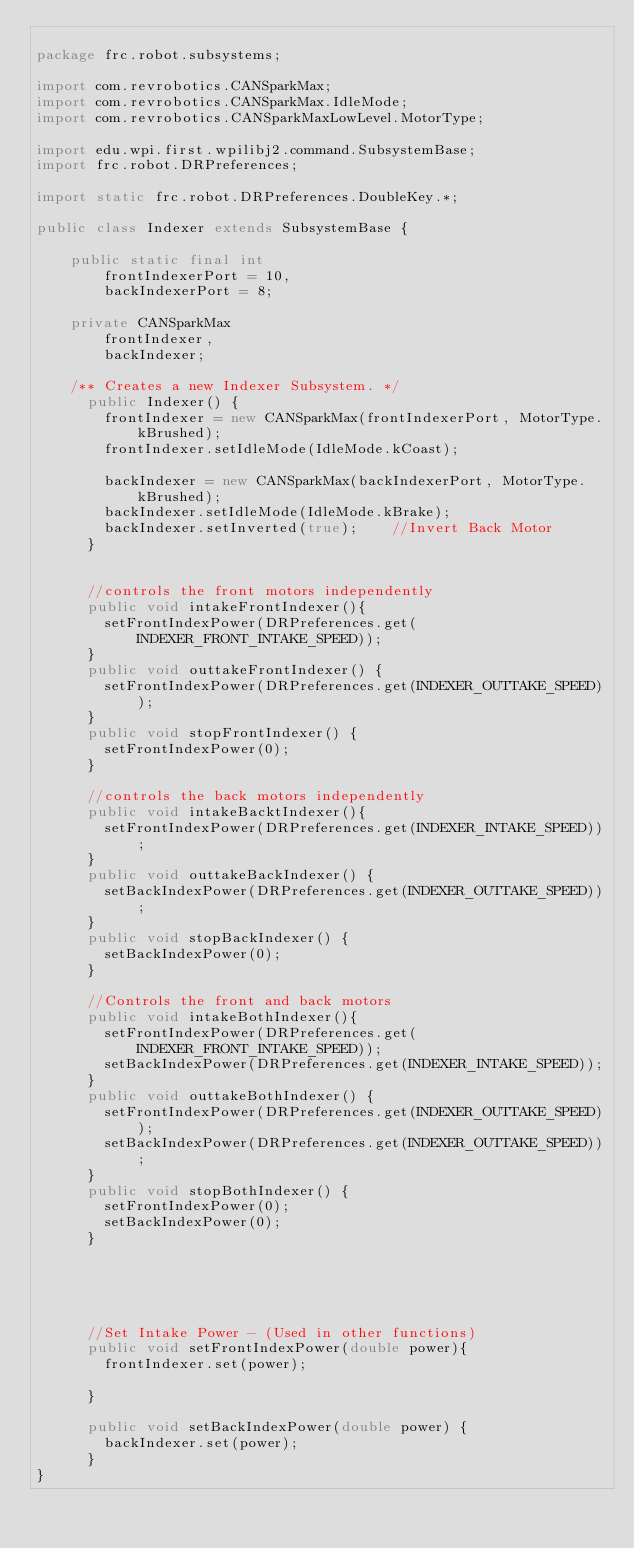<code> <loc_0><loc_0><loc_500><loc_500><_Java_>
package frc.robot.subsystems;

import com.revrobotics.CANSparkMax;
import com.revrobotics.CANSparkMax.IdleMode;
import com.revrobotics.CANSparkMaxLowLevel.MotorType;

import edu.wpi.first.wpilibj2.command.SubsystemBase;
import frc.robot.DRPreferences;

import static frc.robot.DRPreferences.DoubleKey.*;

public class Indexer extends SubsystemBase {

    public static final int
        frontIndexerPort = 10,
        backIndexerPort = 8; 
    
    private CANSparkMax
        frontIndexer,
        backIndexer;
  
    /** Creates a new Indexer Subsystem. */
      public Indexer() {
        frontIndexer = new CANSparkMax(frontIndexerPort, MotorType.kBrushed);
        frontIndexer.setIdleMode(IdleMode.kCoast);
        
        backIndexer = new CANSparkMax(backIndexerPort, MotorType.kBrushed);
        backIndexer.setIdleMode(IdleMode.kBrake);
        backIndexer.setInverted(true);    //Invert Back Motor  
      }


      //controls the front motors independently
      public void intakeFrontIndexer(){
        setFrontIndexPower(DRPreferences.get(INDEXER_FRONT_INTAKE_SPEED));
      }
      public void outtakeFrontIndexer() {
        setFrontIndexPower(DRPreferences.get(INDEXER_OUTTAKE_SPEED));
      }
      public void stopFrontIndexer() {
        setFrontIndexPower(0);
      }

      //controls the back motors independently
      public void intakeBacktIndexer(){
        setFrontIndexPower(DRPreferences.get(INDEXER_INTAKE_SPEED));
      }
      public void outtakeBackIndexer() {
        setBackIndexPower(DRPreferences.get(INDEXER_OUTTAKE_SPEED));
      }
      public void stopBackIndexer() {
        setBackIndexPower(0);
      }

      //Controls the front and back motors
      public void intakeBothIndexer(){
        setFrontIndexPower(DRPreferences.get(INDEXER_FRONT_INTAKE_SPEED));
        setBackIndexPower(DRPreferences.get(INDEXER_INTAKE_SPEED));
      }
      public void outtakeBothIndexer() {
        setFrontIndexPower(DRPreferences.get(INDEXER_OUTTAKE_SPEED));
        setBackIndexPower(DRPreferences.get(INDEXER_OUTTAKE_SPEED));
      }
      public void stopBothIndexer() {
        setFrontIndexPower(0);
        setBackIndexPower(0);
      }





      //Set Intake Power - (Used in other functions)
      public void setFrontIndexPower(double power){
        frontIndexer.set(power);
        
      }

      public void setBackIndexPower(double power) {
        backIndexer.set(power);
      }
}
</code> 